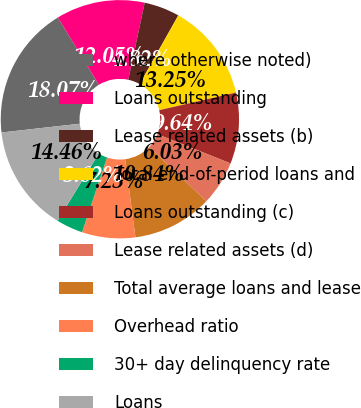<chart> <loc_0><loc_0><loc_500><loc_500><pie_chart><fcel>where otherwise noted)<fcel>Loans outstanding<fcel>Lease related assets (b)<fcel>Total end-of-period loans and<fcel>Loans outstanding (c)<fcel>Lease related assets (d)<fcel>Total average loans and lease<fcel>Overhead ratio<fcel>30+ day delinquency rate<fcel>Loans<nl><fcel>18.07%<fcel>12.05%<fcel>4.82%<fcel>13.25%<fcel>9.64%<fcel>6.03%<fcel>10.84%<fcel>7.23%<fcel>3.62%<fcel>14.46%<nl></chart> 